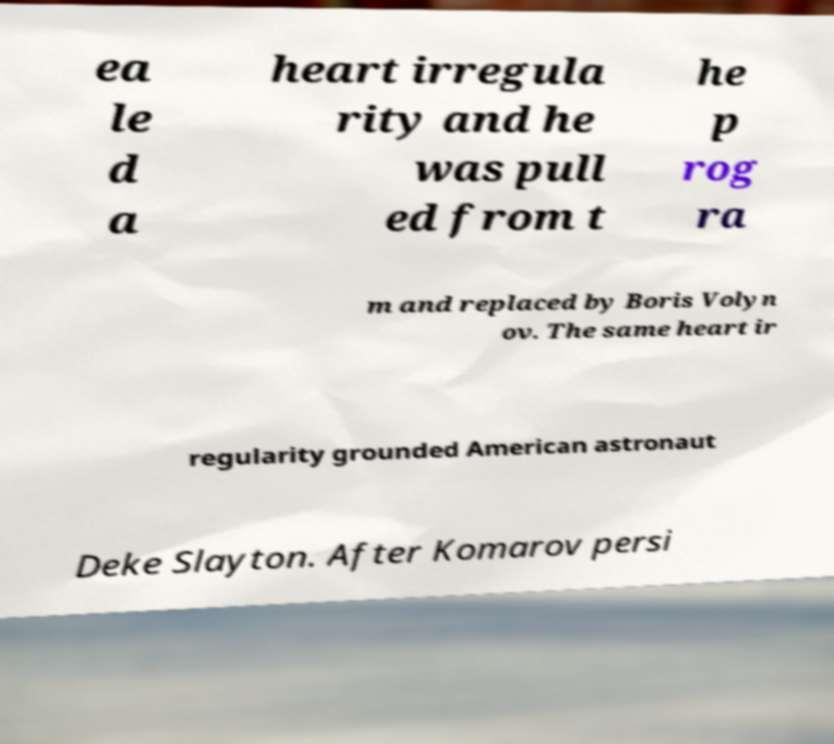Please read and relay the text visible in this image. What does it say? ea le d a heart irregula rity and he was pull ed from t he p rog ra m and replaced by Boris Volyn ov. The same heart ir regularity grounded American astronaut Deke Slayton. After Komarov persi 